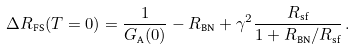<formula> <loc_0><loc_0><loc_500><loc_500>\Delta R _ { \text {FS} } ( T = 0 ) = \frac { 1 } { G _ { \text {A} } ( 0 ) } - R _ { \text {BN} } + \gamma ^ { 2 } \frac { R _ { \text {sf} } } { 1 + R _ { \text {BN} } / R _ { \text {sf} } } \, .</formula> 